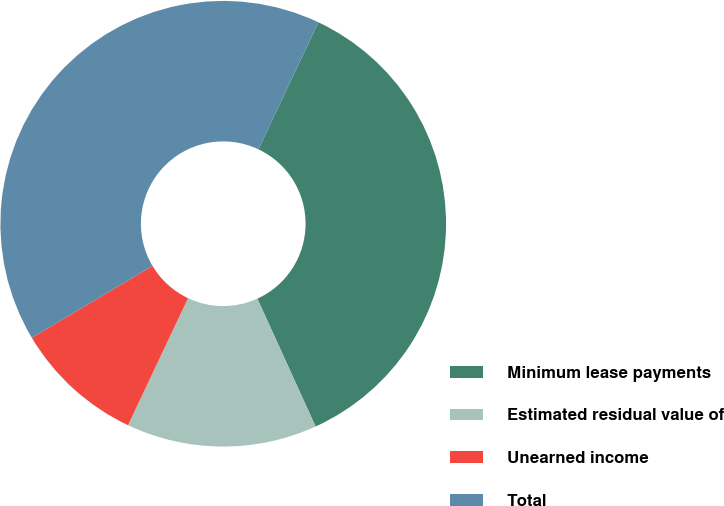<chart> <loc_0><loc_0><loc_500><loc_500><pie_chart><fcel>Minimum lease payments<fcel>Estimated residual value of<fcel>Unearned income<fcel>Total<nl><fcel>36.17%<fcel>13.83%<fcel>9.42%<fcel>40.58%<nl></chart> 